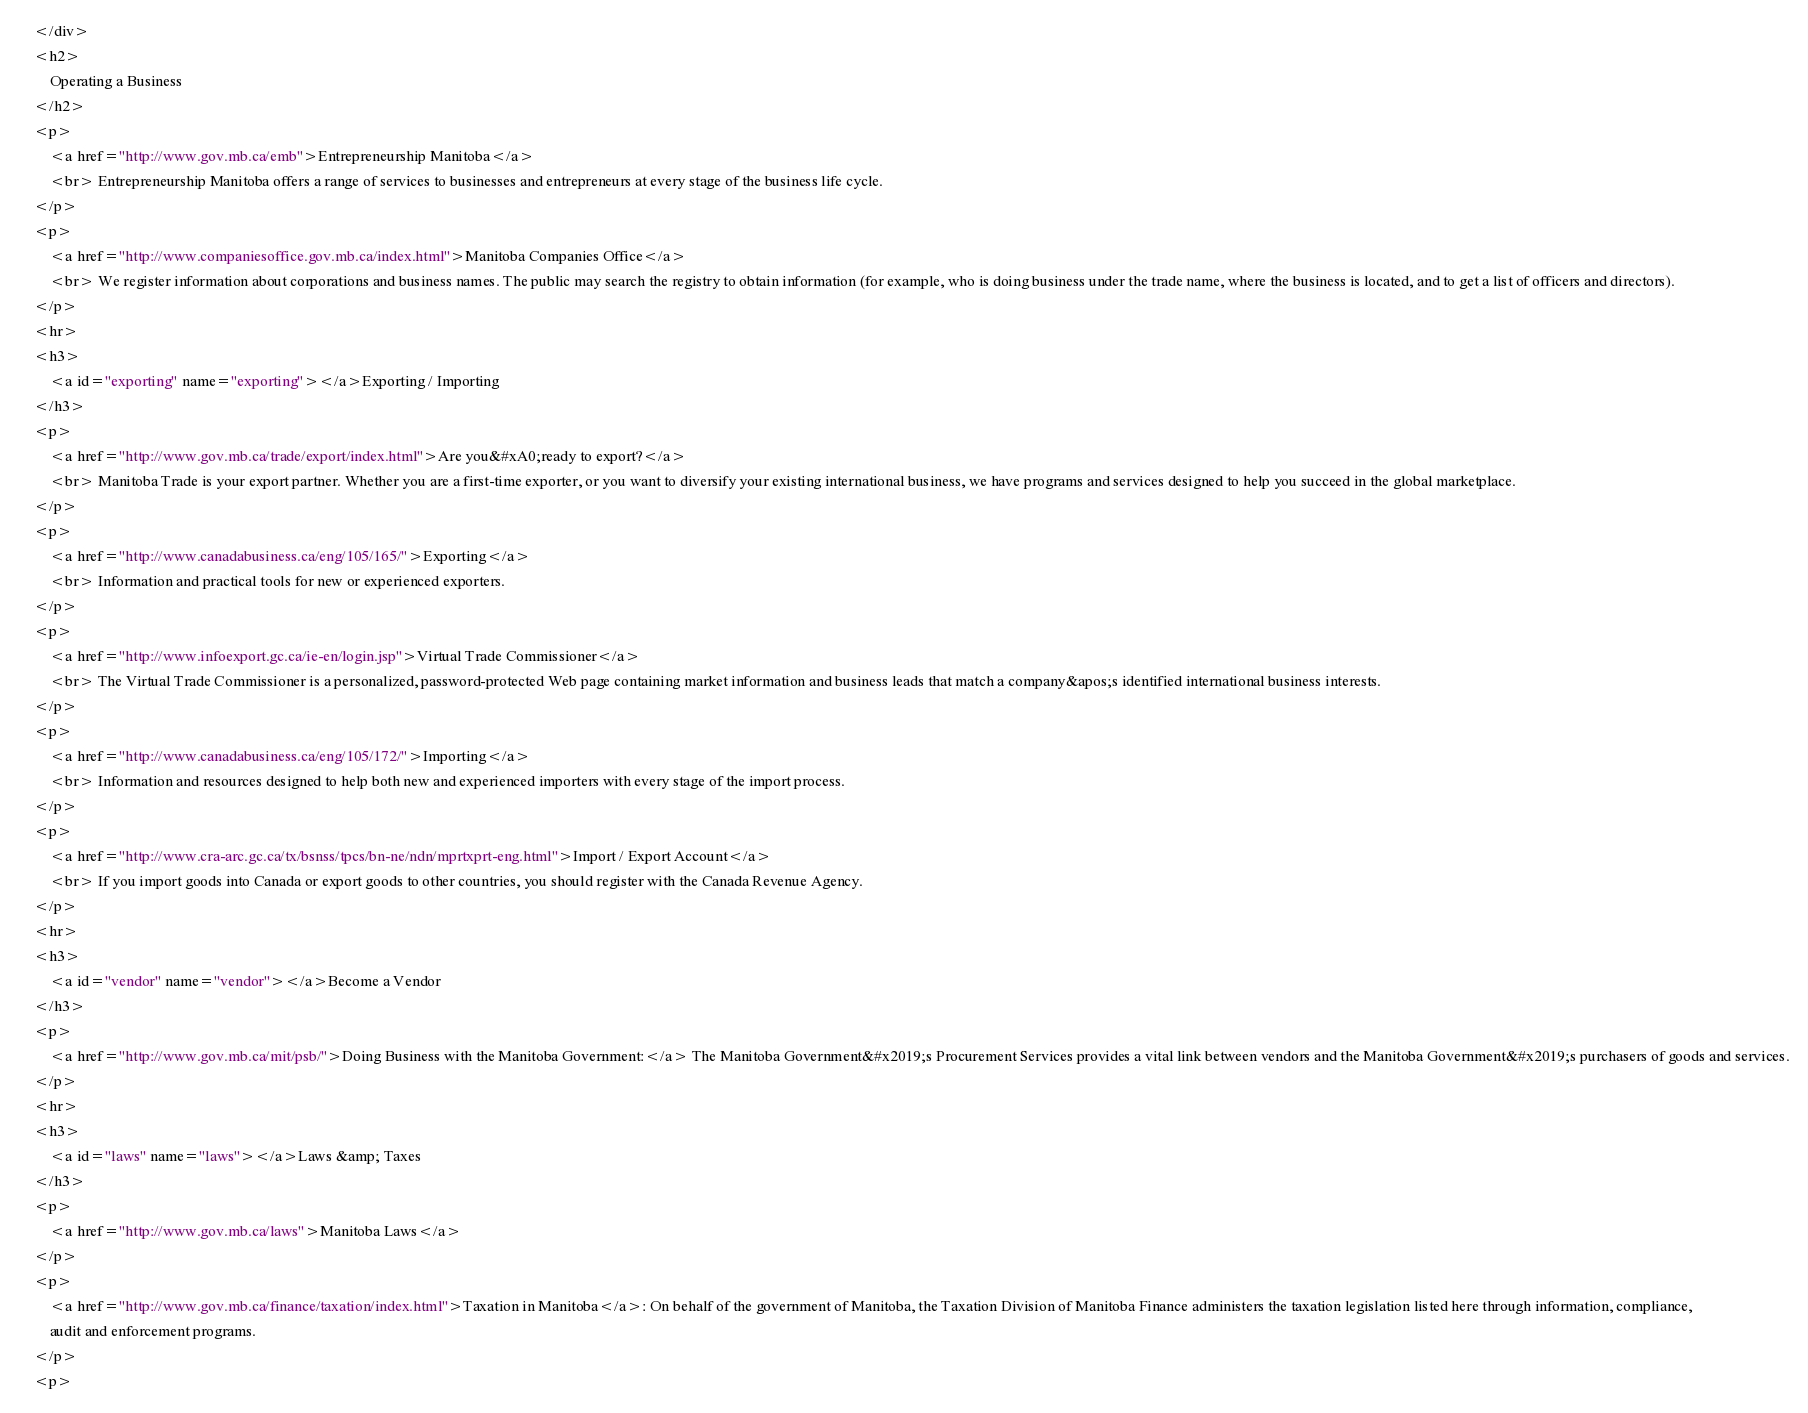Convert code to text. <code><loc_0><loc_0><loc_500><loc_500><_HTML_>    </div>
    <h2>
        Operating a Business
    </h2>
    <p>
        <a href="http://www.gov.mb.ca/emb">Entrepreneurship Manitoba</a>
        <br> Entrepreneurship Manitoba offers a range of services to businesses and entrepreneurs at every stage of the business life cycle.
    </p>
    <p>
        <a href="http://www.companiesoffice.gov.mb.ca/index.html">Manitoba Companies Office</a>
        <br> We register information about corporations and business names. The public may search the registry to obtain information (for example, who is doing business under the trade name, where the business is located, and to get a list of officers and directors).
    </p>
    <hr>
    <h3>
        <a id="exporting" name="exporting"></a>Exporting / Importing
    </h3>
    <p>
        <a href="http://www.gov.mb.ca/trade/export/index.html">Are you&#xA0;ready to export?</a>
        <br> Manitoba Trade is your export partner. Whether you are a first-time exporter, or you want to diversify your existing international business, we have programs and services designed to help you succeed in the global marketplace.
    </p>
    <p>
        <a href="http://www.canadabusiness.ca/eng/105/165/">Exporting</a>
        <br> Information and practical tools for new or experienced exporters.
    </p>
    <p>
        <a href="http://www.infoexport.gc.ca/ie-en/login.jsp">Virtual Trade Commissioner</a>
        <br> The Virtual Trade Commissioner is a personalized, password-protected Web page containing market information and business leads that match a company&apos;s identified international business interests.
    </p>
    <p>
        <a href="http://www.canadabusiness.ca/eng/105/172/">Importing</a>
        <br> Information and resources designed to help both new and experienced importers with every stage of the import process.
    </p>
    <p>
        <a href="http://www.cra-arc.gc.ca/tx/bsnss/tpcs/bn-ne/ndn/mprtxprt-eng.html">Import / Export Account</a>
        <br> If you import goods into Canada or export goods to other countries, you should register with the Canada Revenue Agency.
    </p>
    <hr>
    <h3>
        <a id="vendor" name="vendor"></a>Become a Vendor
    </h3>
    <p>
        <a href="http://www.gov.mb.ca/mit/psb/">Doing Business with the Manitoba Government:</a> The Manitoba Government&#x2019;s Procurement Services provides a vital link between vendors and the Manitoba Government&#x2019;s purchasers of goods and services.
    </p>
    <hr>
    <h3>
        <a id="laws" name="laws"></a>Laws &amp; Taxes
    </h3>
    <p>
        <a href="http://www.gov.mb.ca/laws">Manitoba Laws</a>
    </p>
    <p>
        <a href="http://www.gov.mb.ca/finance/taxation/index.html">Taxation in Manitoba</a>: On behalf of the government of Manitoba, the Taxation Division of Manitoba Finance administers the taxation legislation listed here through information, compliance,
        audit and enforcement programs.
    </p>
    <p></code> 